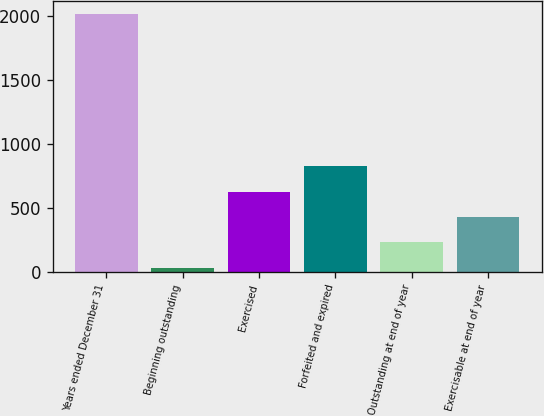<chart> <loc_0><loc_0><loc_500><loc_500><bar_chart><fcel>Years ended December 31<fcel>Beginning outstanding<fcel>Exercised<fcel>Forfeited and expired<fcel>Outstanding at end of year<fcel>Exercisable at end of year<nl><fcel>2014<fcel>32<fcel>626.6<fcel>824.8<fcel>230.2<fcel>428.4<nl></chart> 